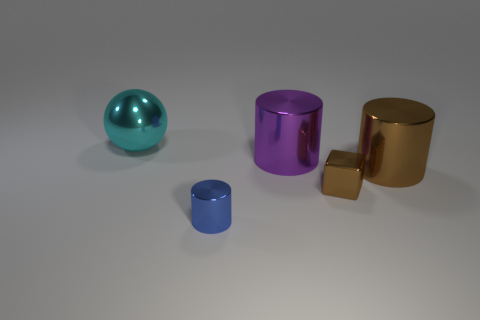There is a tiny thing right of the tiny blue metal cylinder; does it have the same shape as the cyan metallic thing?
Give a very brief answer. No. Are there more cyan metallic things that are on the right side of the purple thing than big balls?
Provide a succinct answer. No. Is there anything else that has the same material as the big cyan ball?
Your answer should be compact. Yes. What shape is the big metallic object that is the same color as the tiny block?
Offer a terse response. Cylinder. How many cylinders are large purple things or brown shiny things?
Offer a very short reply. 2. There is a large shiny object that is right of the small thing behind the blue metal object; what is its color?
Your response must be concise. Brown. There is a large ball; is it the same color as the tiny metallic thing that is behind the blue metallic cylinder?
Your answer should be compact. No. What size is the blue thing that is made of the same material as the ball?
Your answer should be very brief. Small. There is a cylinder that is the same color as the cube; what is its size?
Provide a succinct answer. Large. Do the sphere and the small cylinder have the same color?
Ensure brevity in your answer.  No. 